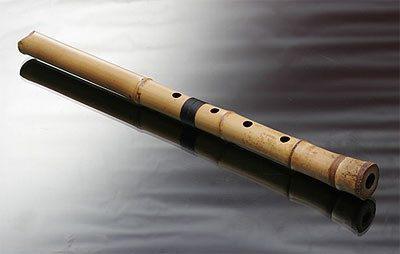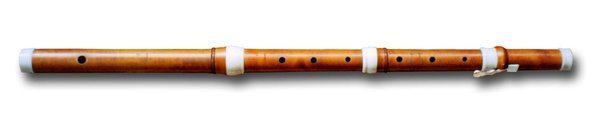The first image is the image on the left, the second image is the image on the right. Considering the images on both sides, is "One writing implement is visible." valid? Answer yes or no. No. The first image is the image on the left, the second image is the image on the right. For the images shown, is this caption "There are two flutes." true? Answer yes or no. Yes. 